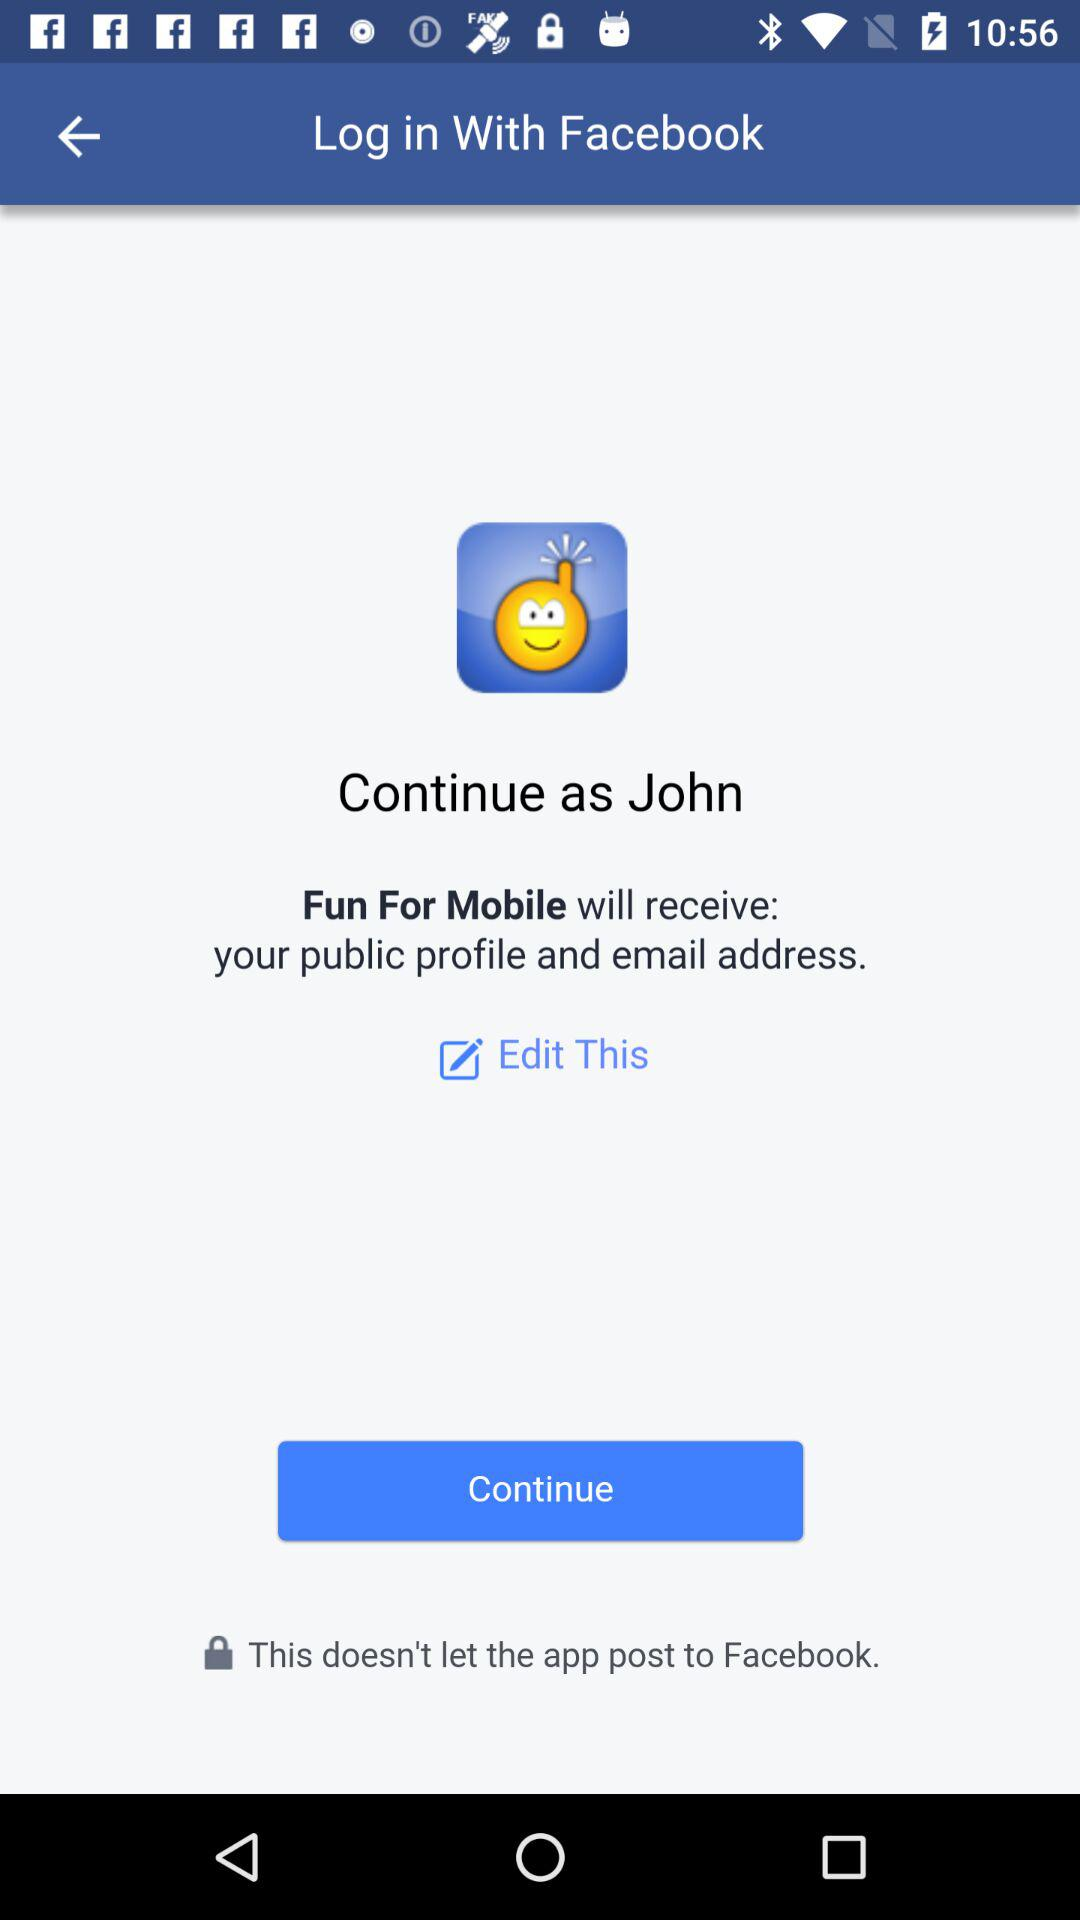What application is asking for permission? The application that is asking for permission is "Fun For Mobile". 